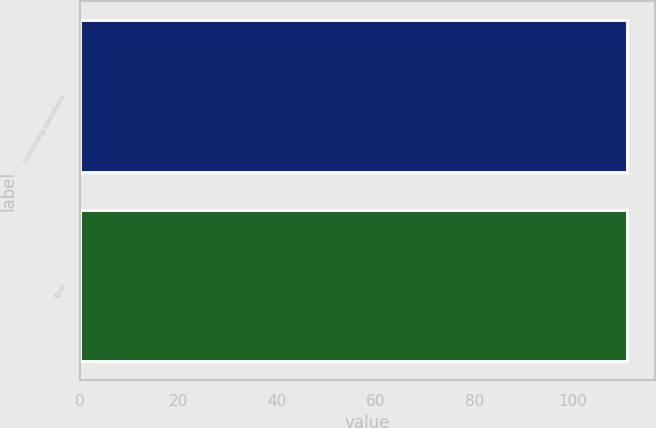Convert chart to OTSL. <chart><loc_0><loc_0><loc_500><loc_500><bar_chart><fcel>Continuing operations<fcel>Total<nl><fcel>111<fcel>111.1<nl></chart> 